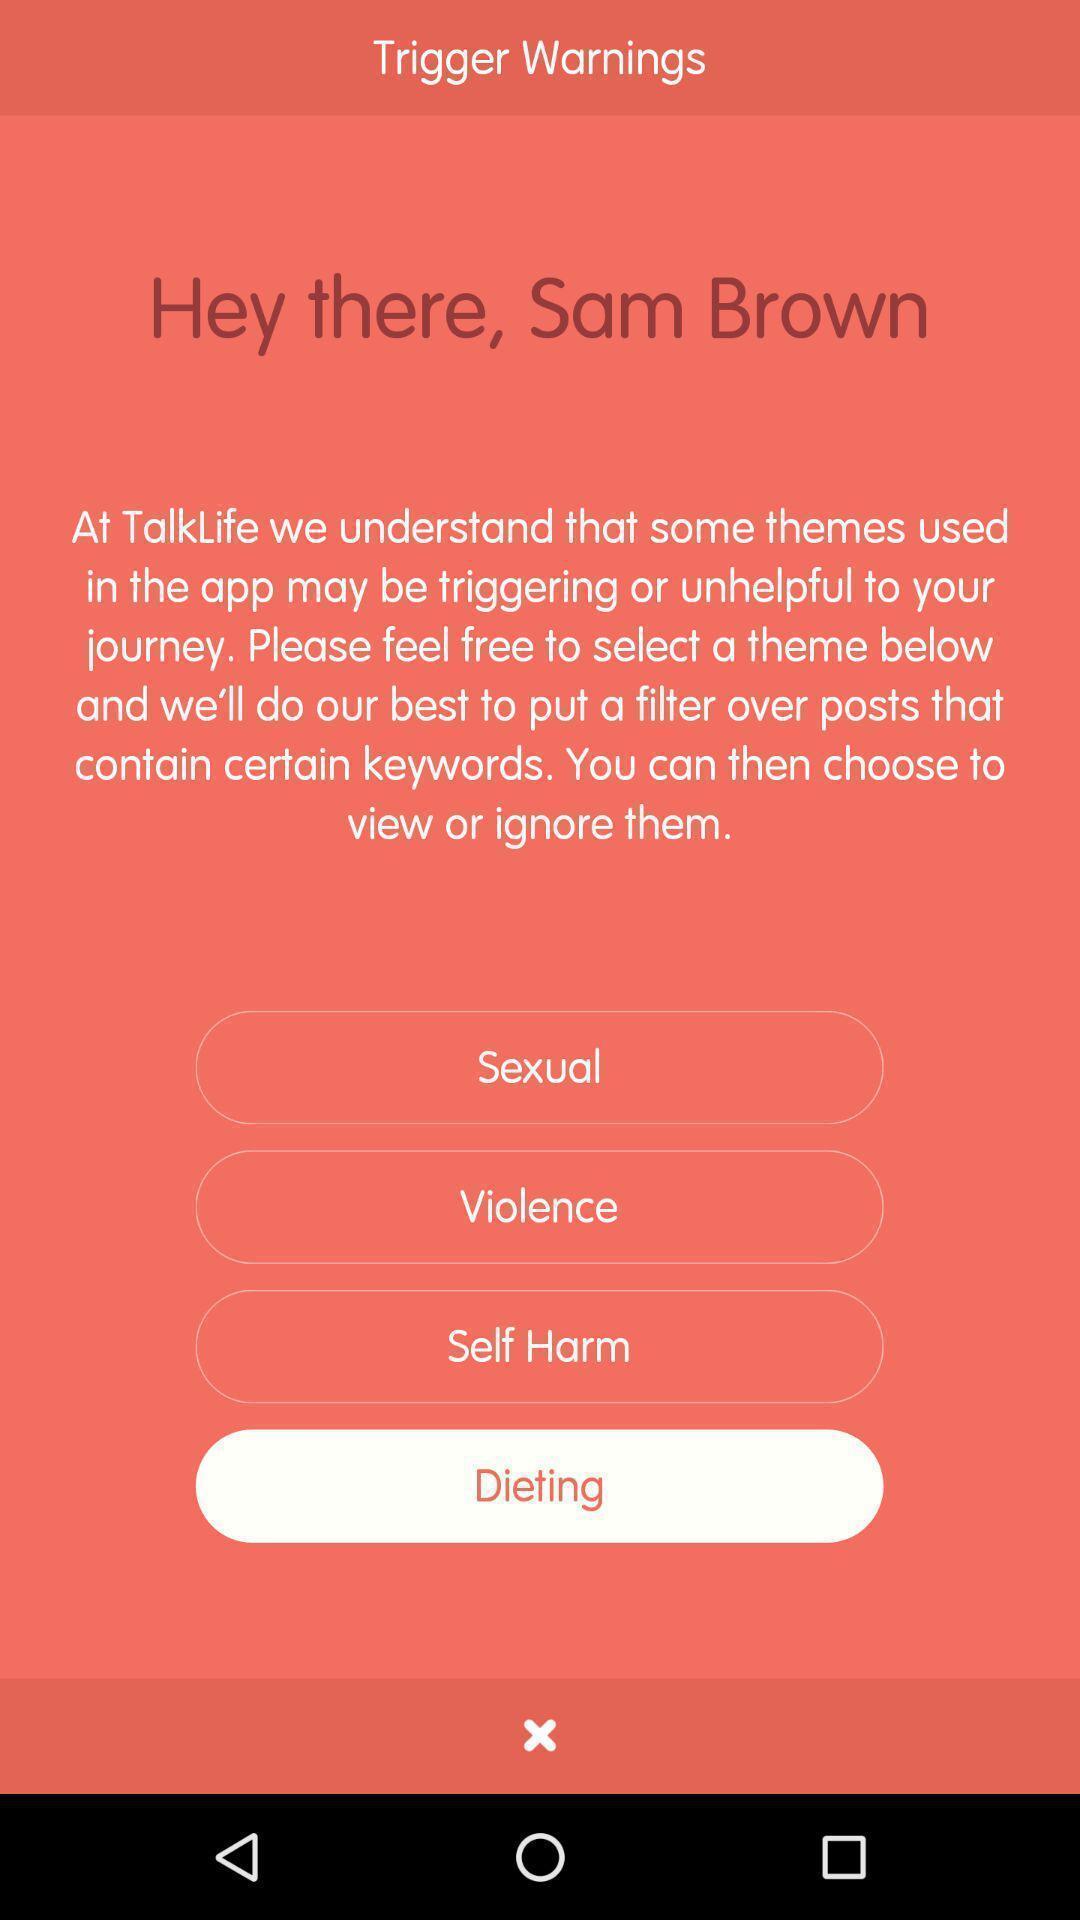What details can you identify in this image? Various options displayed to select. 